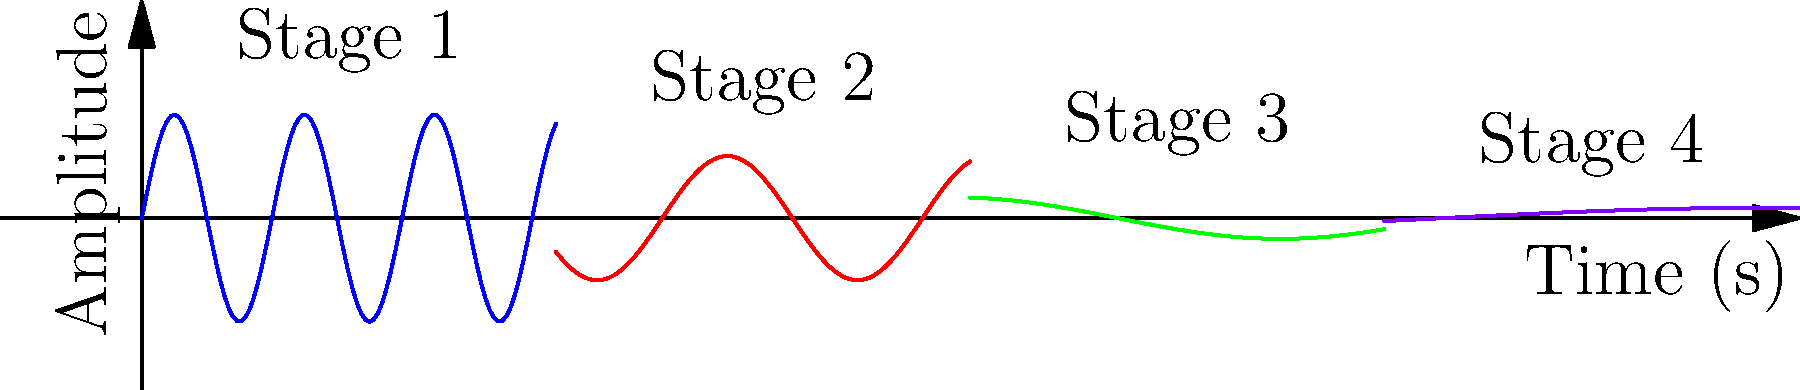Based on the EEG waveform patterns shown in the graph, which stage of anesthesia is characterized by high-frequency, low-amplitude waves? To answer this question, we need to analyze the EEG waveform patterns shown in the graph and understand the characteristics of each stage of anesthesia:

1. Stage 1 (0-2 seconds): This stage shows high-frequency, low-amplitude waves. The waveform has the highest frequency and lowest amplitude compared to the other stages.

2. Stage 2 (2-4 seconds): The frequency decreases and the amplitude increases slightly compared to Stage 1.

3. Stage 3 (4-6 seconds): The frequency continues to decrease, and the amplitude increases further.

4. Stage 4 (6-8 seconds): This stage shows the lowest frequency and highest amplitude waves.

In anesthesia, the progression from consciousness to deep anesthesia is typically associated with a decrease in frequency and an increase in amplitude of EEG waves. The initial stage of anesthesia, which is closest to the awake state, is characterized by high-frequency, low-amplitude waves.

Therefore, the stage of anesthesia characterized by high-frequency, low-amplitude waves is Stage 1.
Answer: Stage 1 